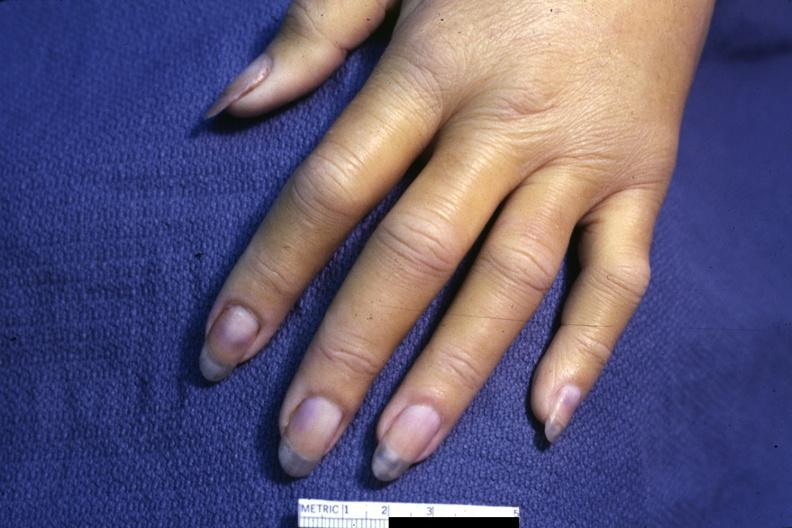what requires dark room to see subtle distal phalangeal cyanosis?
Answer the question using a single word or phrase. Case of dic not bad photo 